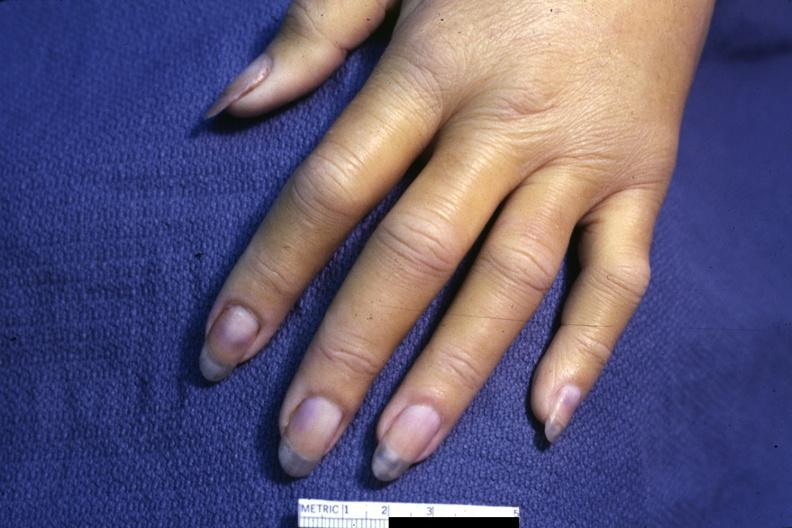what requires dark room to see subtle distal phalangeal cyanosis?
Answer the question using a single word or phrase. Case of dic not bad photo 